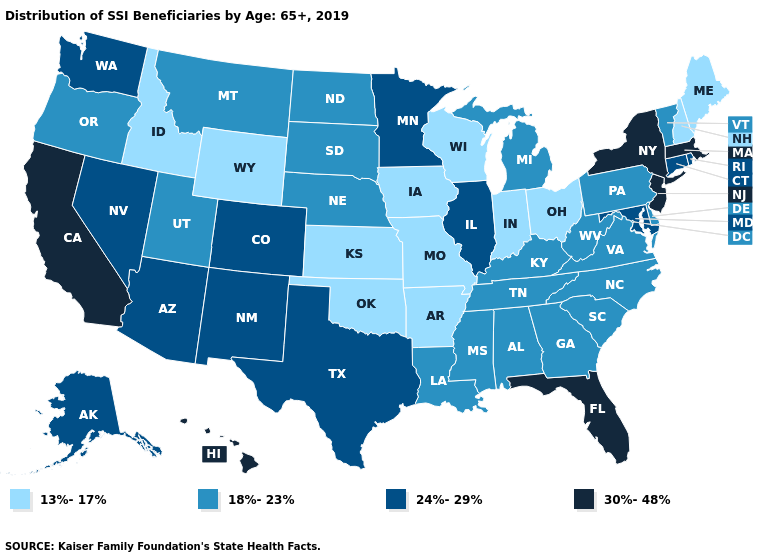What is the lowest value in the MidWest?
Keep it brief. 13%-17%. Which states hav the highest value in the South?
Be succinct. Florida. What is the value of Montana?
Write a very short answer. 18%-23%. What is the highest value in the USA?
Give a very brief answer. 30%-48%. What is the value of Nebraska?
Be succinct. 18%-23%. Which states have the lowest value in the USA?
Write a very short answer. Arkansas, Idaho, Indiana, Iowa, Kansas, Maine, Missouri, New Hampshire, Ohio, Oklahoma, Wisconsin, Wyoming. Does the first symbol in the legend represent the smallest category?
Short answer required. Yes. How many symbols are there in the legend?
Write a very short answer. 4. What is the value of Kansas?
Concise answer only. 13%-17%. Name the states that have a value in the range 13%-17%?
Quick response, please. Arkansas, Idaho, Indiana, Iowa, Kansas, Maine, Missouri, New Hampshire, Ohio, Oklahoma, Wisconsin, Wyoming. Name the states that have a value in the range 18%-23%?
Give a very brief answer. Alabama, Delaware, Georgia, Kentucky, Louisiana, Michigan, Mississippi, Montana, Nebraska, North Carolina, North Dakota, Oregon, Pennsylvania, South Carolina, South Dakota, Tennessee, Utah, Vermont, Virginia, West Virginia. Name the states that have a value in the range 30%-48%?
Give a very brief answer. California, Florida, Hawaii, Massachusetts, New Jersey, New York. What is the highest value in the Northeast ?
Short answer required. 30%-48%. Does Utah have the highest value in the West?
Answer briefly. No. What is the value of Indiana?
Write a very short answer. 13%-17%. 